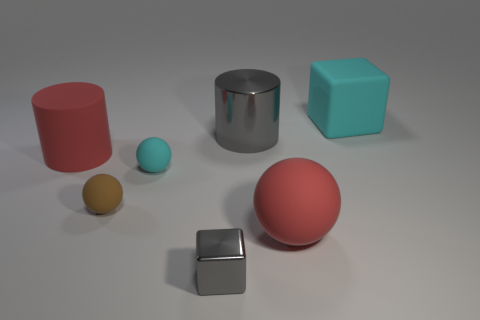What is the significance of the different colors and shapes present in the image? The variety of colors and shapes might represent diversity or the concept of uniqueness within unity. The image provides a visual experience that stimulates thoughts on the inherent differences and similarities among objects, akin to individuals in a society. 